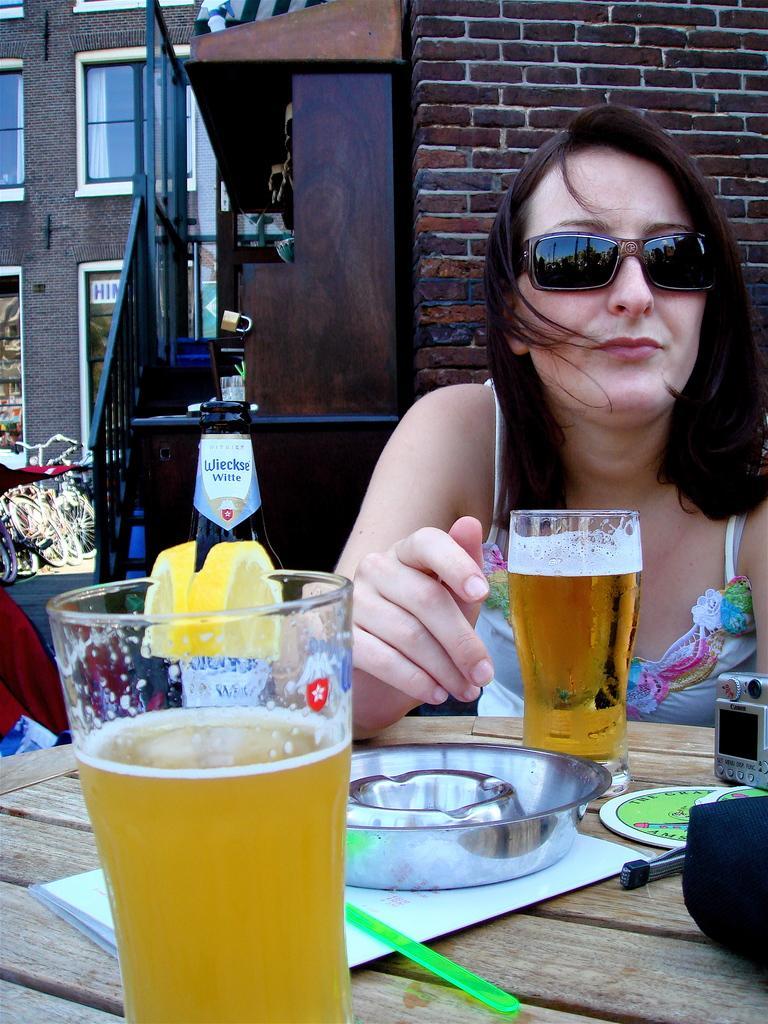Please provide a concise description of this image. In this image we can see a lady wearing goggles. In front of her there is a table on which there are glasses, bottles and other objects. In the background of the image there is a building with windows, wall, bicycles. 